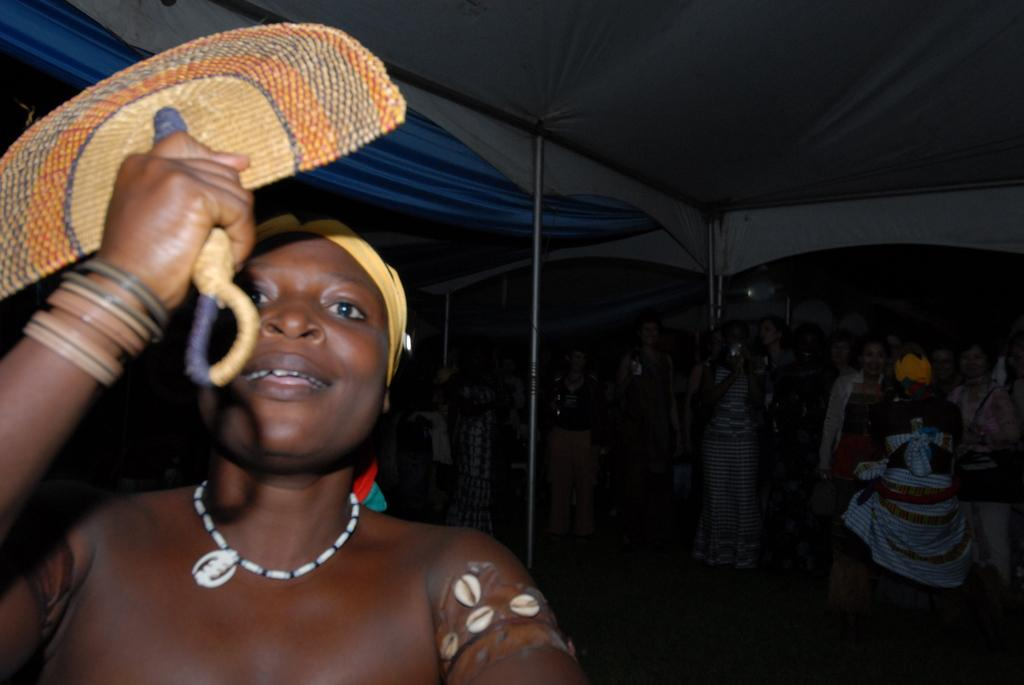What is the person in the image doing? The person in the image is holding a hand fan. How does the person appear to feel in the image? The person is smiling, which suggests they are happy or enjoying themselves. What can be seen in the background of the image? There is a group of people, poles, tents, and some objects in the background of the image. How many babies are present in the lunchroom in the image? There is no lunchroom or babies present in the image. What type of man is standing near the tents in the image? There is no man standing near the tents in the image; only the person holding the hand fan and the group of people in the background are visible. 